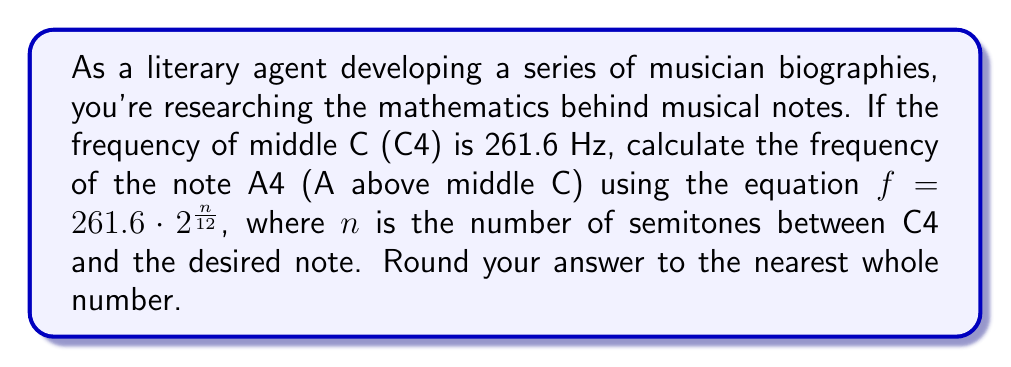Can you answer this question? To solve this problem, we'll follow these steps:

1) First, we need to determine the number of semitones between C4 and A4. In the standard 12-tone scale:
   C → C# → D → D# → E → F → F# → G → G# → A
   This is a total of 9 semitones.

2) Now we can plug this into our equation:
   $f = 261.6 \cdot 2^{\frac{n}{12}}$
   $f = 261.6 \cdot 2^{\frac{9}{12}}$

3) Let's simplify the exponent:
   $f = 261.6 \cdot 2^{\frac{3}{4}}$

4) Now we can calculate this:
   $f = 261.6 \cdot 1.6817928305074290860622509524664$

5) Multiplying:
   $f = 440.0000000000000000000000000000624$

6) Rounding to the nearest whole number:
   $f \approx 440$ Hz
Answer: 440 Hz 